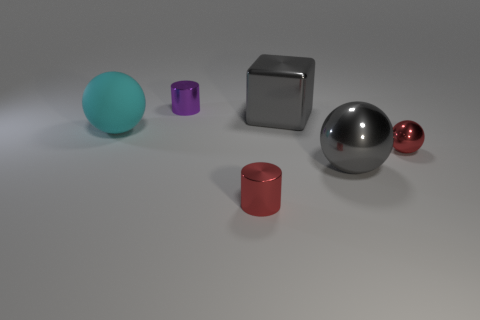Add 2 cylinders. How many objects exist? 8 Subtract all blocks. How many objects are left? 5 Add 4 large cyan matte blocks. How many large cyan matte blocks exist? 4 Subtract 0 blue spheres. How many objects are left? 6 Subtract all large yellow matte things. Subtract all large blocks. How many objects are left? 5 Add 2 big gray metal cubes. How many big gray metal cubes are left? 3 